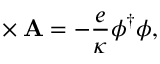Convert formula to latex. <formula><loc_0><loc_0><loc_500><loc_500>{ \nabla } \times { A } = - \frac { e } { \kappa } \phi ^ { \dagger } \phi ,</formula> 